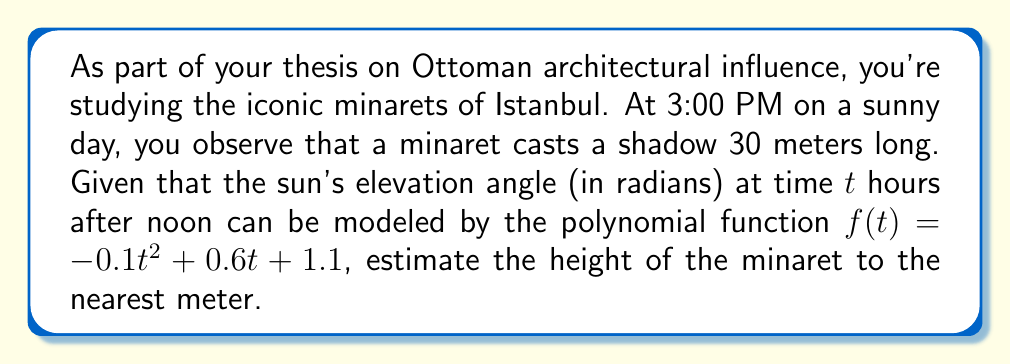Could you help me with this problem? Let's approach this step-by-step:

1) First, we need to determine the sun's elevation angle at 3:00 PM. Since this is 3 hours after noon, we'll use $t = 3$ in our function:

   $f(3) = -0.1(3)^2 + 0.6(3) + 1.1$
   $= -0.1(9) + 1.8 + 1.1$
   $= -0.9 + 1.8 + 1.1$
   $= 2$ radians

2) Now we have a right triangle where:
   - The adjacent side is the shadow length (30 meters)
   - The angle between the ground and the sun's rays is 2 radians
   - We need to find the opposite side (the minaret's height)

3) We can use the tangent function to relate these:

   $\tan(\text{angle}) = \frac{\text{opposite}}{\text{adjacent}}$

4) Substituting our known values:

   $\tan(2) = \frac{\text{height}}{30}$

5) Solving for height:

   $\text{height} = 30 \tan(2)$

6) Using a calculator (or approximating $\tan(2) \approx 2.185$):

   $\text{height} \approx 30 * 2.185 \approx 65.55$ meters

7) Rounding to the nearest meter as requested:

   $\text{height} \approx 66$ meters
Answer: The estimated height of the minaret is 66 meters. 